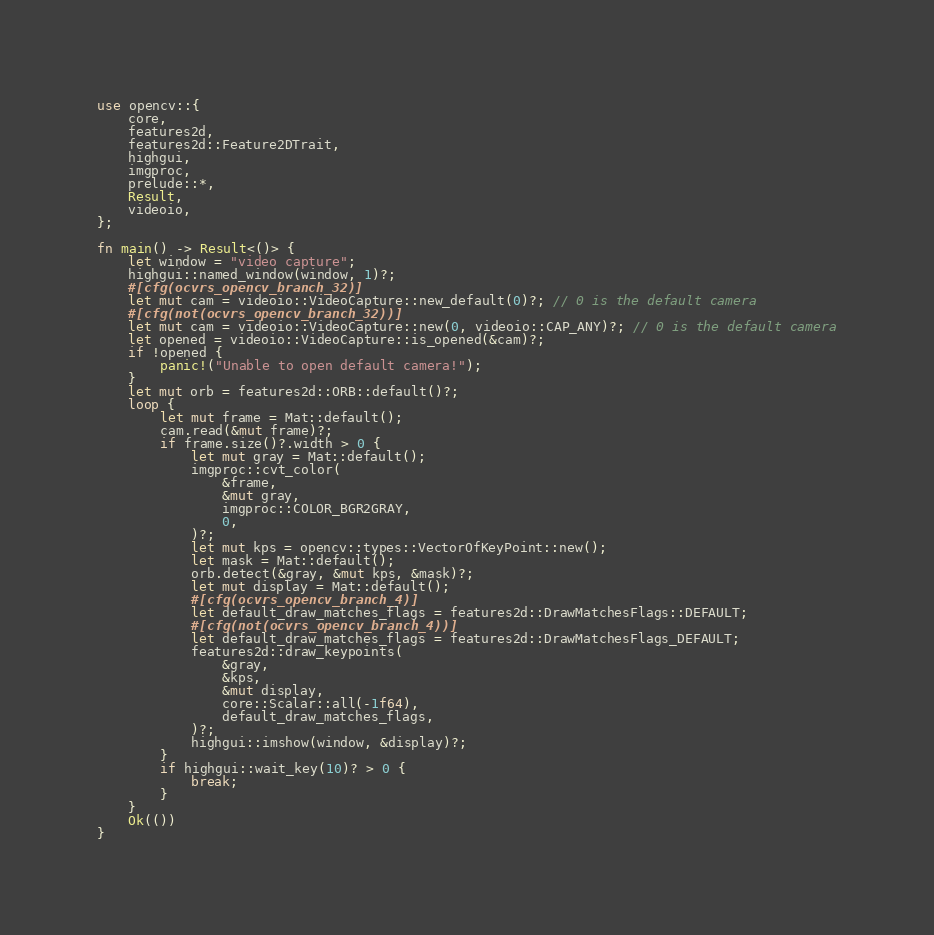<code> <loc_0><loc_0><loc_500><loc_500><_Rust_>use opencv::{
	core,
	features2d,
	features2d::Feature2DTrait,
	highgui,
	imgproc,
	prelude::*,
	Result,
	videoio,
};

fn main() -> Result<()> {
	let window = "video capture";
	highgui::named_window(window, 1)?;
	#[cfg(ocvrs_opencv_branch_32)]
	let mut cam = videoio::VideoCapture::new_default(0)?; // 0 is the default camera
	#[cfg(not(ocvrs_opencv_branch_32))]
	let mut cam = videoio::VideoCapture::new(0, videoio::CAP_ANY)?; // 0 is the default camera
	let opened = videoio::VideoCapture::is_opened(&cam)?;
	if !opened {
		panic!("Unable to open default camera!");
	}
	let mut orb = features2d::ORB::default()?;
	loop {
		let mut frame = Mat::default();
		cam.read(&mut frame)?;
		if frame.size()?.width > 0 {
			let mut gray = Mat::default();
			imgproc::cvt_color(
				&frame,
				&mut gray,
				imgproc::COLOR_BGR2GRAY,
				0,
			)?;
			let mut kps = opencv::types::VectorOfKeyPoint::new();
			let mask = Mat::default();
			orb.detect(&gray, &mut kps, &mask)?;
			let mut display = Mat::default();
			#[cfg(ocvrs_opencv_branch_4)]
			let default_draw_matches_flags = features2d::DrawMatchesFlags::DEFAULT;
			#[cfg(not(ocvrs_opencv_branch_4))]
			let default_draw_matches_flags = features2d::DrawMatchesFlags_DEFAULT;
			features2d::draw_keypoints(
				&gray,
				&kps,
				&mut display,
				core::Scalar::all(-1f64),
				default_draw_matches_flags,
			)?;
			highgui::imshow(window, &display)?;
		}
		if highgui::wait_key(10)? > 0 {
			break;
		}
	}
	Ok(())
}
</code> 